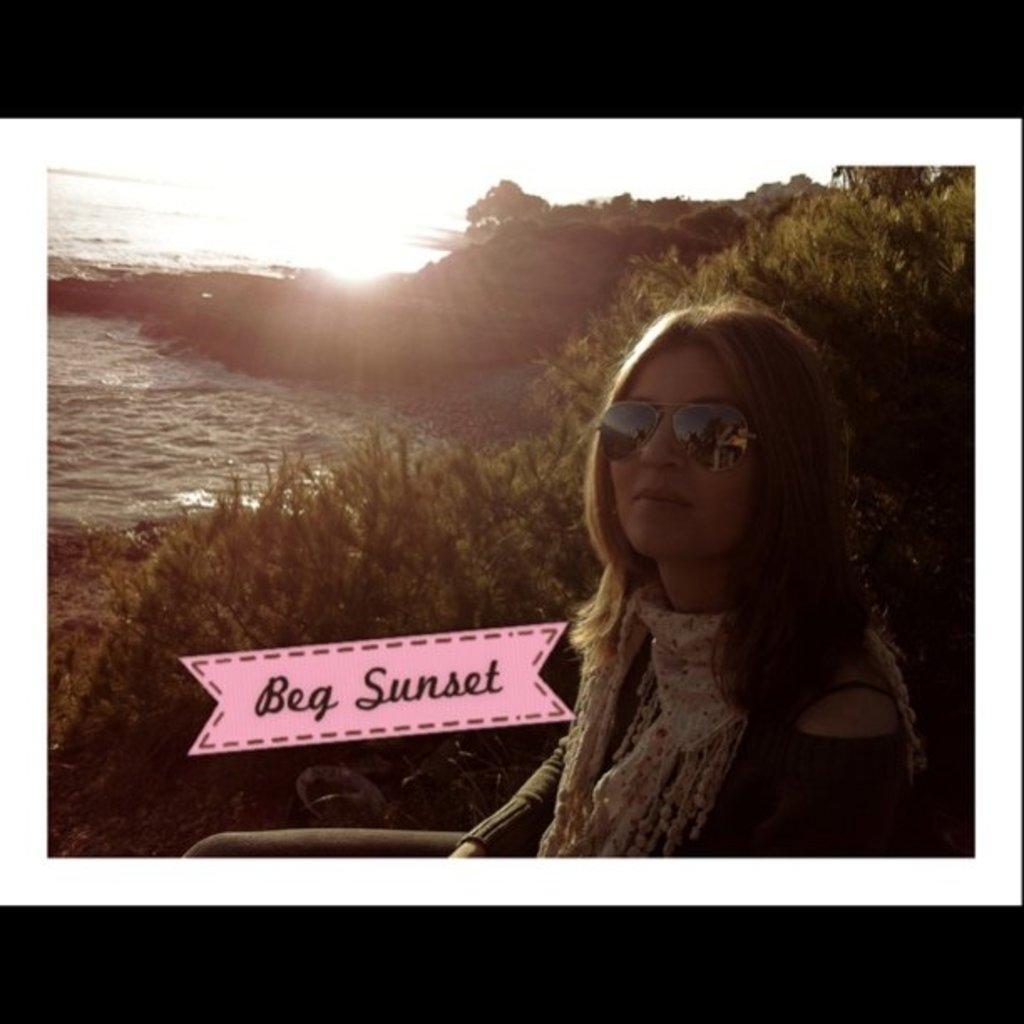Describe this image in one or two sentences. In this picture there is a girl on the right side of the image and there is water on the left side of the image and there are plants on the right side of the image. 